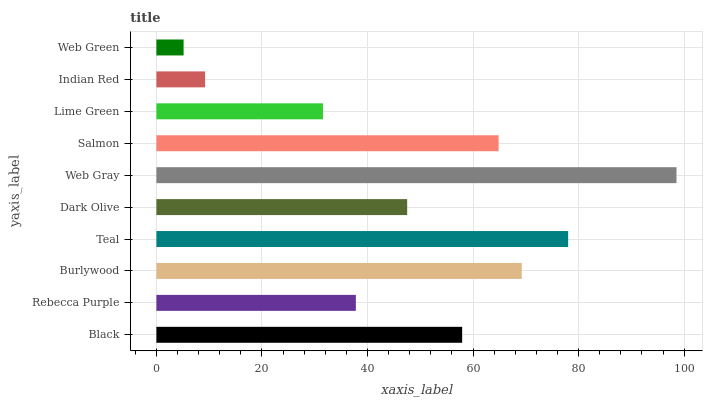Is Web Green the minimum?
Answer yes or no. Yes. Is Web Gray the maximum?
Answer yes or no. Yes. Is Rebecca Purple the minimum?
Answer yes or no. No. Is Rebecca Purple the maximum?
Answer yes or no. No. Is Black greater than Rebecca Purple?
Answer yes or no. Yes. Is Rebecca Purple less than Black?
Answer yes or no. Yes. Is Rebecca Purple greater than Black?
Answer yes or no. No. Is Black less than Rebecca Purple?
Answer yes or no. No. Is Black the high median?
Answer yes or no. Yes. Is Dark Olive the low median?
Answer yes or no. Yes. Is Indian Red the high median?
Answer yes or no. No. Is Teal the low median?
Answer yes or no. No. 